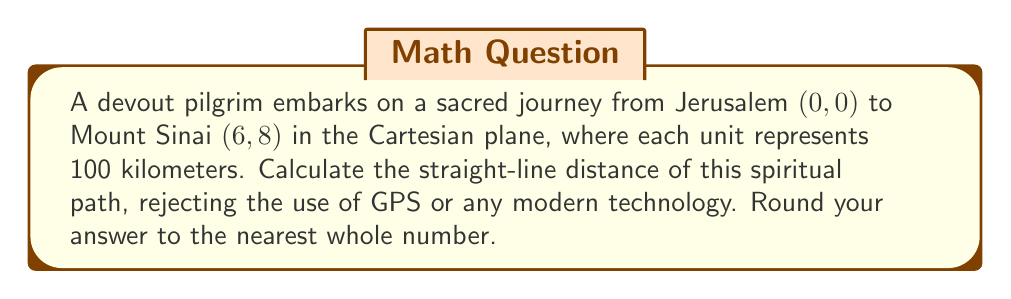Can you solve this math problem? To find the distance between two points in the Cartesian plane, we use the distance formula derived from the Pythagorean theorem:

$$d = \sqrt{(x_2 - x_1)^2 + (y_2 - y_1)^2}$$

Where $(x_1, y_1)$ is the starting point and $(x_2, y_2)$ is the ending point.

Step 1: Identify the coordinates
- Jerusalem: $(x_1, y_1) = (0, 0)$
- Mount Sinai: $(x_2, y_2) = (6, 8)$

Step 2: Apply the distance formula
$$d = \sqrt{(6 - 0)^2 + (8 - 0)^2}$$

Step 3: Simplify
$$d = \sqrt{6^2 + 8^2}$$
$$d = \sqrt{36 + 64}$$
$$d = \sqrt{100}$$

Step 4: Calculate the square root
$$d = 10$$

Step 5: Interpret the result
Since each unit represents 100 kilometers, the actual distance is:
$$10 \times 100 = 1000$$ kilometers

Therefore, the straight-line distance of the pilgrimage is 1000 kilometers.

[asy]
unitsize(0.5cm);
draw((-1,-1)--(7,9), gray);
dot((0,0));
dot((6,8));
label("Jerusalem (0, 0)", (0,0), SW);
label("Mount Sinai (6, 8)", (6,8), NE);
label("1000 km", (3,4), SE);
[/asy]
Answer: 1000 km 